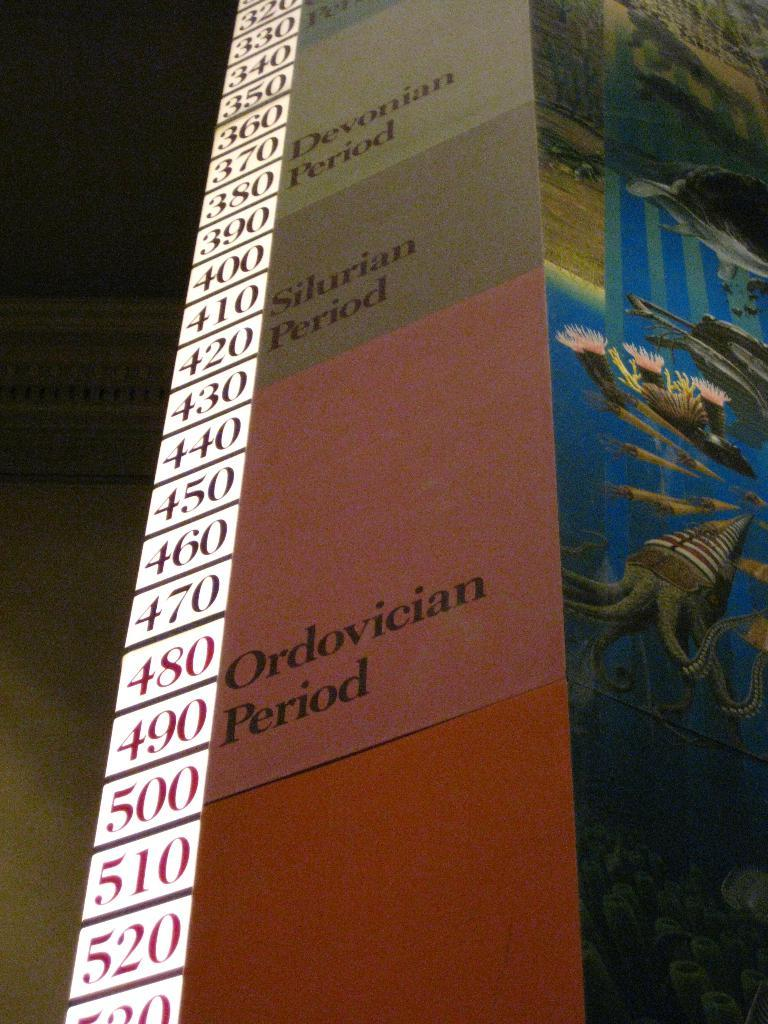What object is present in the image that has colors and writing on it? There is a board in the image that has orange, pink, and gray colors and writing on it. What types of information can be found on the board? Besides the colors, there is writing and numbers on the board. How does the growth of the pickle affect the board in the image? There is no pickle present in the image, so its growth cannot affect the board. 